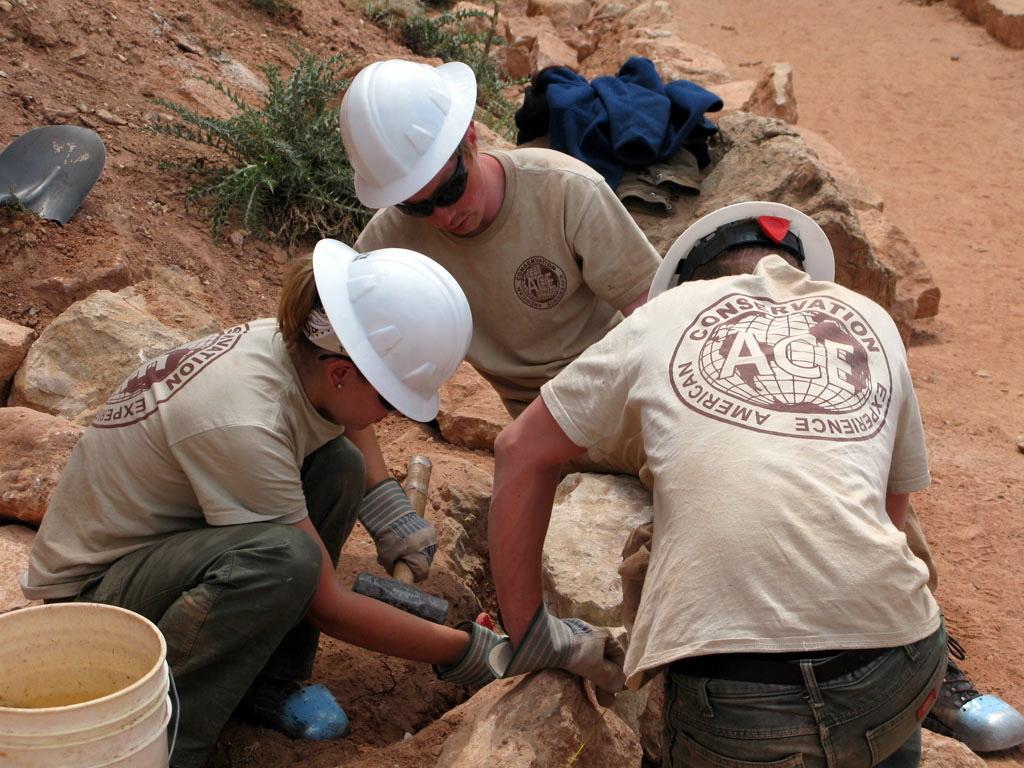Could you give a brief overview of what you see in this image? In this image I can see few people wearing the ash and grey color dresses. These people are holding the rocks. To the left I can see the bucket. In the back there are plants and the clothes. 